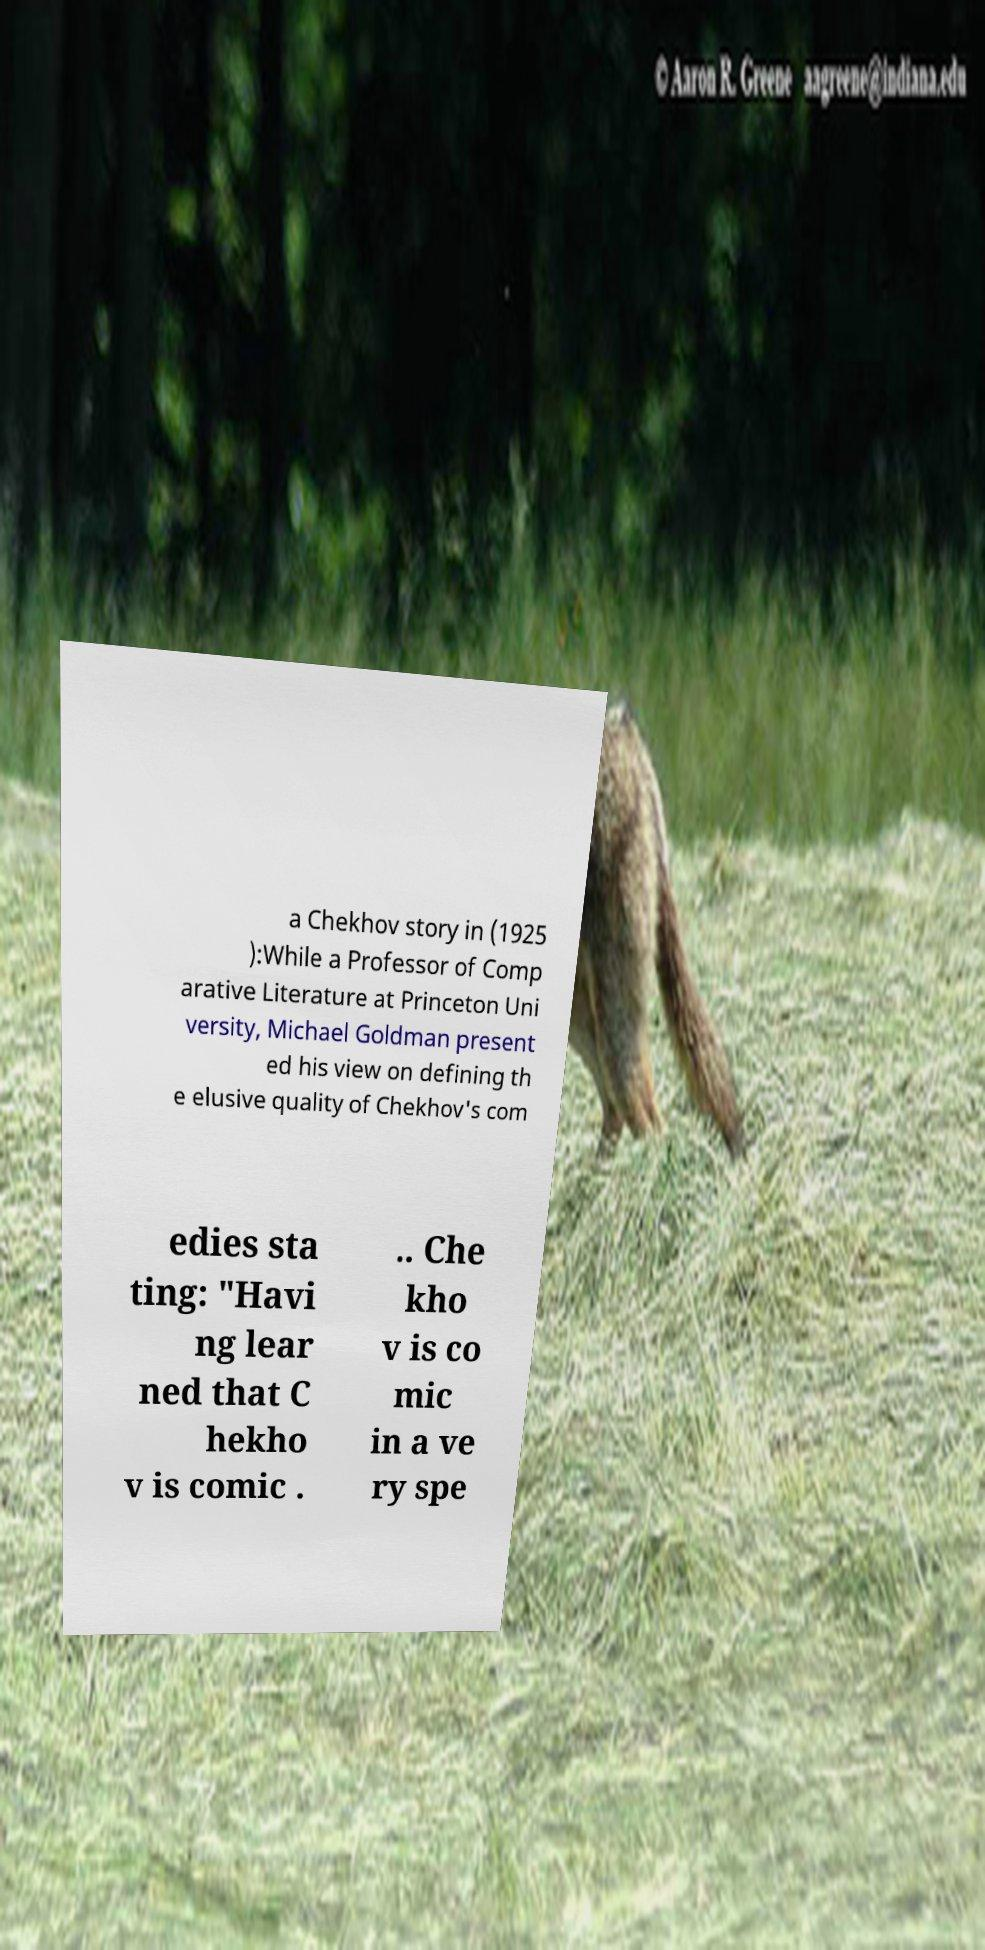Could you extract and type out the text from this image? a Chekhov story in (1925 ):While a Professor of Comp arative Literature at Princeton Uni versity, Michael Goldman present ed his view on defining th e elusive quality of Chekhov's com edies sta ting: "Havi ng lear ned that C hekho v is comic . .. Che kho v is co mic in a ve ry spe 